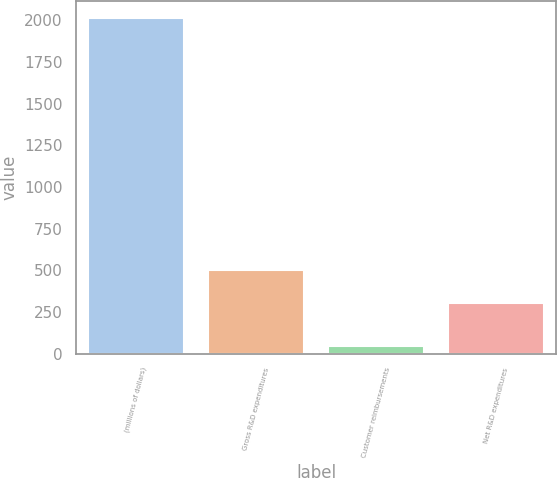<chart> <loc_0><loc_0><loc_500><loc_500><bar_chart><fcel>(millions of dollars)<fcel>Gross R&D expenditures<fcel>Customer reimbursements<fcel>Net R&D expenditures<nl><fcel>2013<fcel>499.78<fcel>47.2<fcel>303.2<nl></chart> 